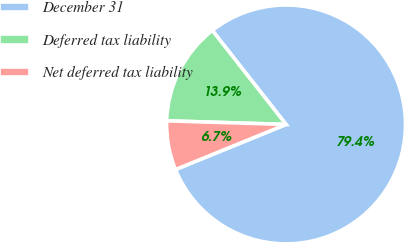Convert chart to OTSL. <chart><loc_0><loc_0><loc_500><loc_500><pie_chart><fcel>December 31<fcel>Deferred tax liability<fcel>Net deferred tax liability<nl><fcel>79.42%<fcel>13.93%<fcel>6.65%<nl></chart> 